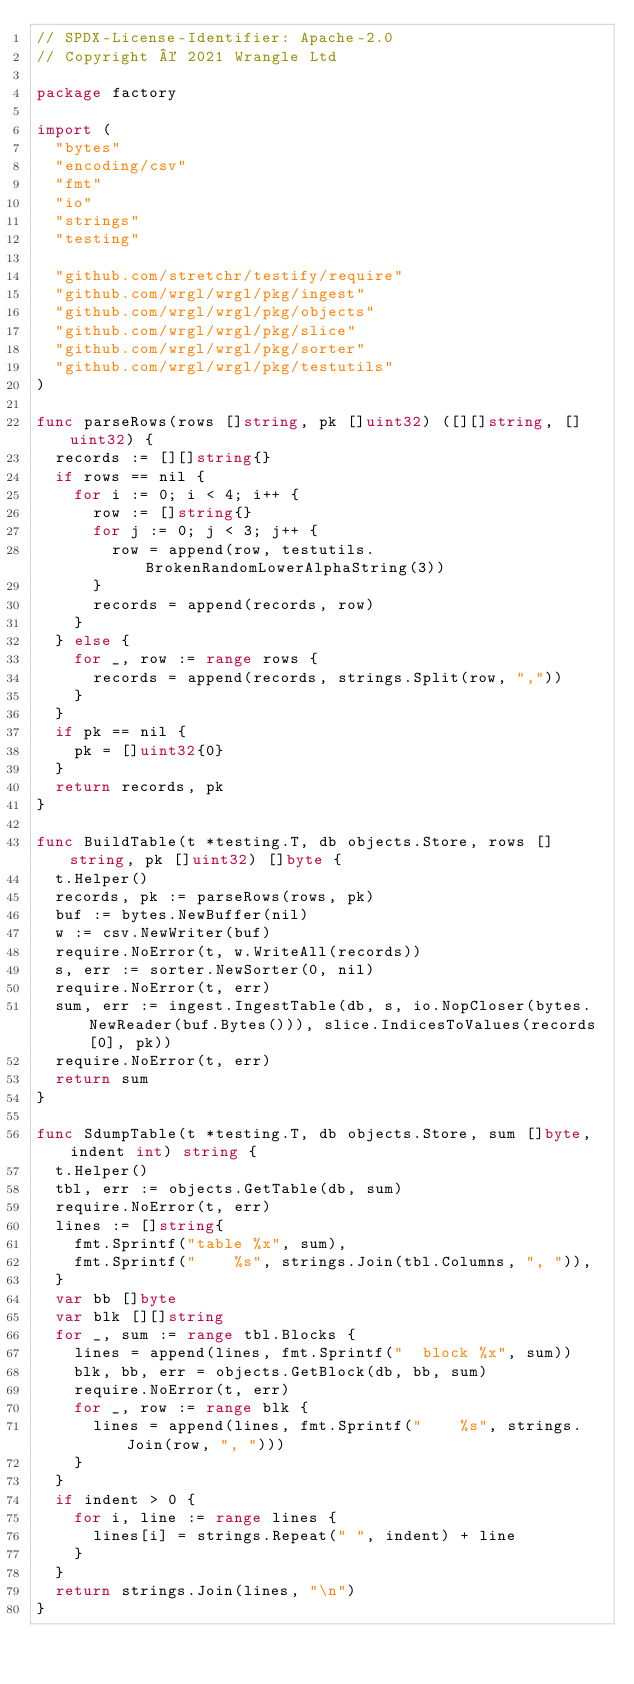Convert code to text. <code><loc_0><loc_0><loc_500><loc_500><_Go_>// SPDX-License-Identifier: Apache-2.0
// Copyright © 2021 Wrangle Ltd

package factory

import (
	"bytes"
	"encoding/csv"
	"fmt"
	"io"
	"strings"
	"testing"

	"github.com/stretchr/testify/require"
	"github.com/wrgl/wrgl/pkg/ingest"
	"github.com/wrgl/wrgl/pkg/objects"
	"github.com/wrgl/wrgl/pkg/slice"
	"github.com/wrgl/wrgl/pkg/sorter"
	"github.com/wrgl/wrgl/pkg/testutils"
)

func parseRows(rows []string, pk []uint32) ([][]string, []uint32) {
	records := [][]string{}
	if rows == nil {
		for i := 0; i < 4; i++ {
			row := []string{}
			for j := 0; j < 3; j++ {
				row = append(row, testutils.BrokenRandomLowerAlphaString(3))
			}
			records = append(records, row)
		}
	} else {
		for _, row := range rows {
			records = append(records, strings.Split(row, ","))
		}
	}
	if pk == nil {
		pk = []uint32{0}
	}
	return records, pk
}

func BuildTable(t *testing.T, db objects.Store, rows []string, pk []uint32) []byte {
	t.Helper()
	records, pk := parseRows(rows, pk)
	buf := bytes.NewBuffer(nil)
	w := csv.NewWriter(buf)
	require.NoError(t, w.WriteAll(records))
	s, err := sorter.NewSorter(0, nil)
	require.NoError(t, err)
	sum, err := ingest.IngestTable(db, s, io.NopCloser(bytes.NewReader(buf.Bytes())), slice.IndicesToValues(records[0], pk))
	require.NoError(t, err)
	return sum
}

func SdumpTable(t *testing.T, db objects.Store, sum []byte, indent int) string {
	t.Helper()
	tbl, err := objects.GetTable(db, sum)
	require.NoError(t, err)
	lines := []string{
		fmt.Sprintf("table %x", sum),
		fmt.Sprintf("    %s", strings.Join(tbl.Columns, ", ")),
	}
	var bb []byte
	var blk [][]string
	for _, sum := range tbl.Blocks {
		lines = append(lines, fmt.Sprintf("  block %x", sum))
		blk, bb, err = objects.GetBlock(db, bb, sum)
		require.NoError(t, err)
		for _, row := range blk {
			lines = append(lines, fmt.Sprintf("    %s", strings.Join(row, ", ")))
		}
	}
	if indent > 0 {
		for i, line := range lines {
			lines[i] = strings.Repeat(" ", indent) + line
		}
	}
	return strings.Join(lines, "\n")
}
</code> 